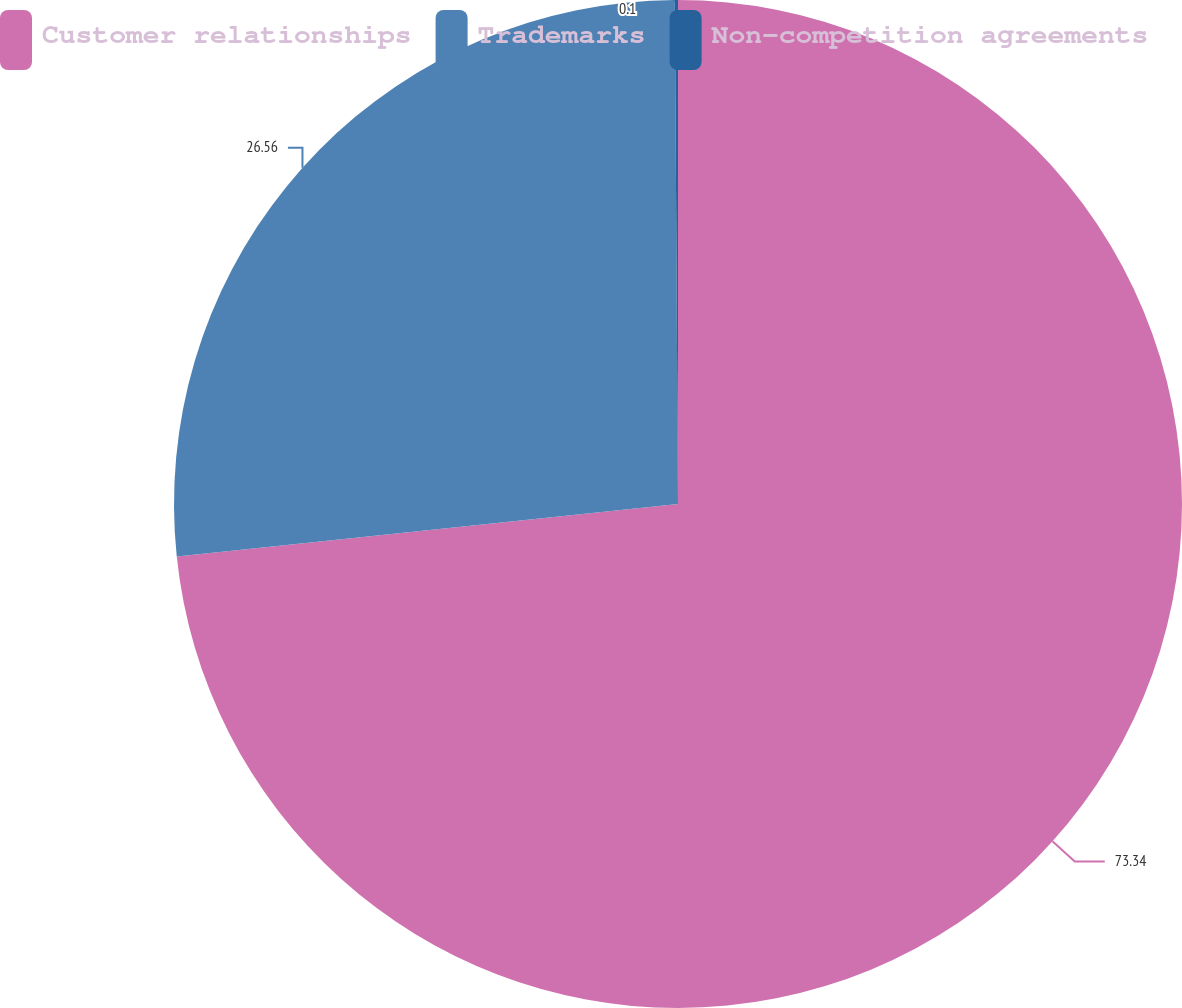Convert chart to OTSL. <chart><loc_0><loc_0><loc_500><loc_500><pie_chart><fcel>Customer relationships<fcel>Trademarks<fcel>Non-competition agreements<nl><fcel>73.34%<fcel>26.56%<fcel>0.1%<nl></chart> 